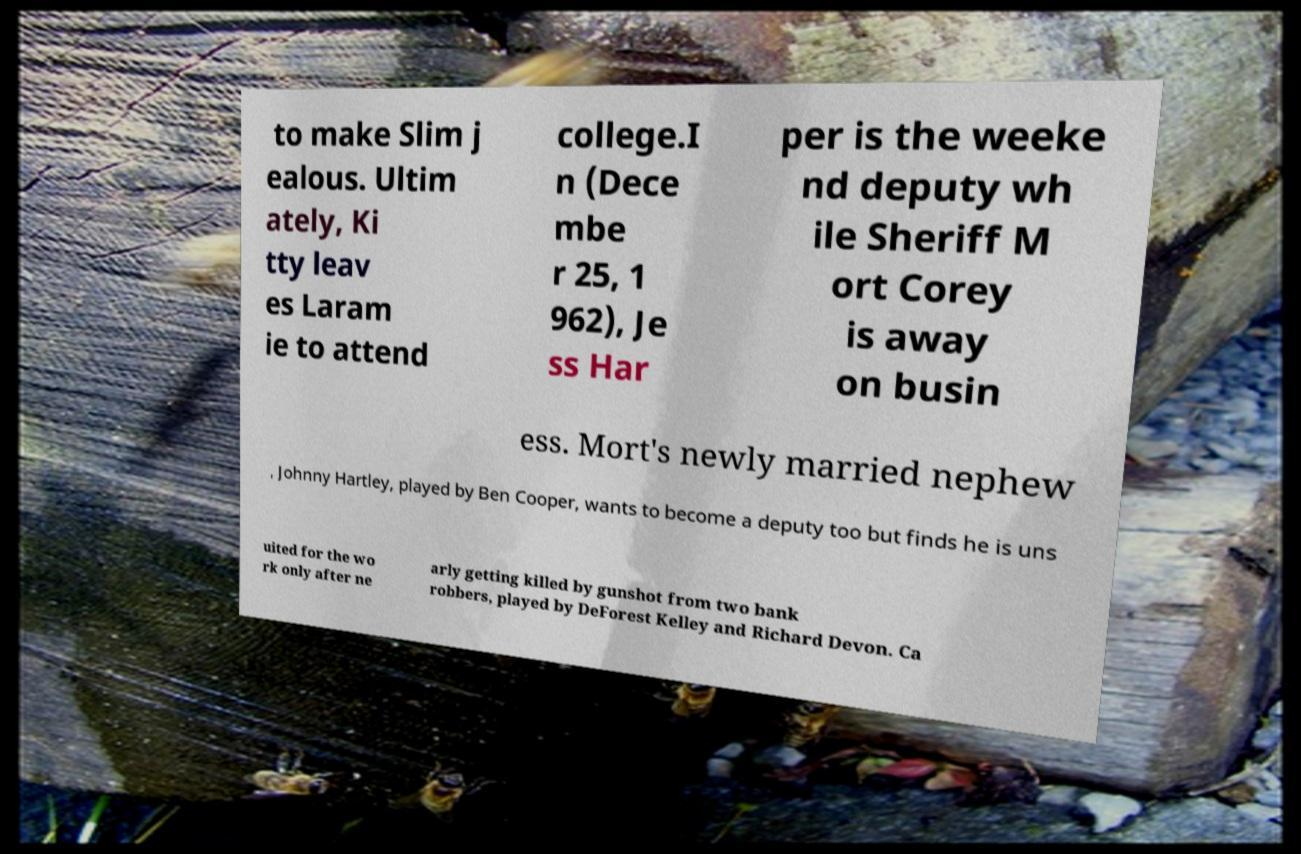Can you read and provide the text displayed in the image?This photo seems to have some interesting text. Can you extract and type it out for me? to make Slim j ealous. Ultim ately, Ki tty leav es Laram ie to attend college.I n (Dece mbe r 25, 1 962), Je ss Har per is the weeke nd deputy wh ile Sheriff M ort Corey is away on busin ess. Mort's newly married nephew , Johnny Hartley, played by Ben Cooper, wants to become a deputy too but finds he is uns uited for the wo rk only after ne arly getting killed by gunshot from two bank robbers, played by DeForest Kelley and Richard Devon. Ca 